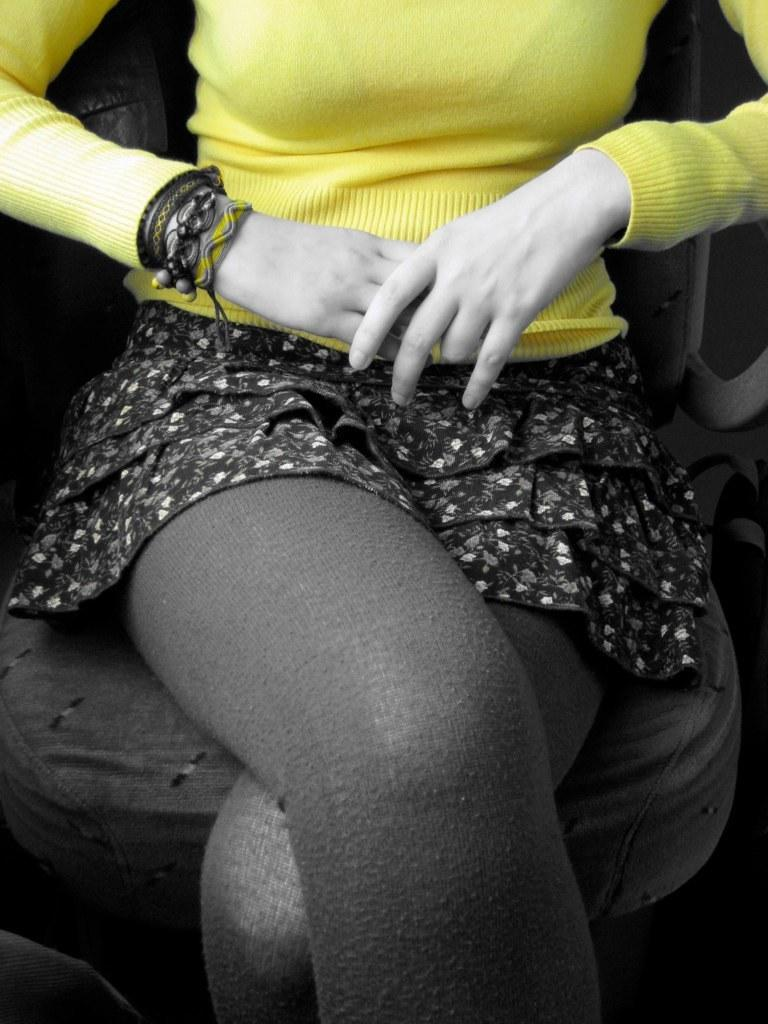Who is the main subject in the image? There is a lady in the image. What is the lady doing in the image? The lady is sitting on a chair. What type of clothing is the lady wearing? The lady is wearing a skirt and a shirt. Is there any accessory visible on the lady in the image? Yes, the lady is wearing a band. What company does the lady work for in the image? There is no information about the lady's company in the image. Can you tell me how many steps the lady is taking in the image? The lady is sitting on a chair in the image, so she is not taking any steps. 